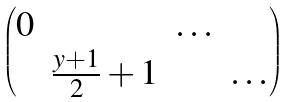<formula> <loc_0><loc_0><loc_500><loc_500>\begin{pmatrix} 0 & & \dots \\ & \frac { y + 1 } { 2 } + 1 & & \dots \end{pmatrix}</formula> 